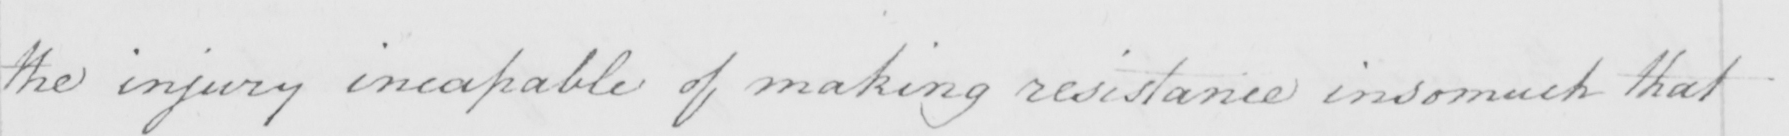Can you tell me what this handwritten text says? the injury incapable of making resistance insomuch that 